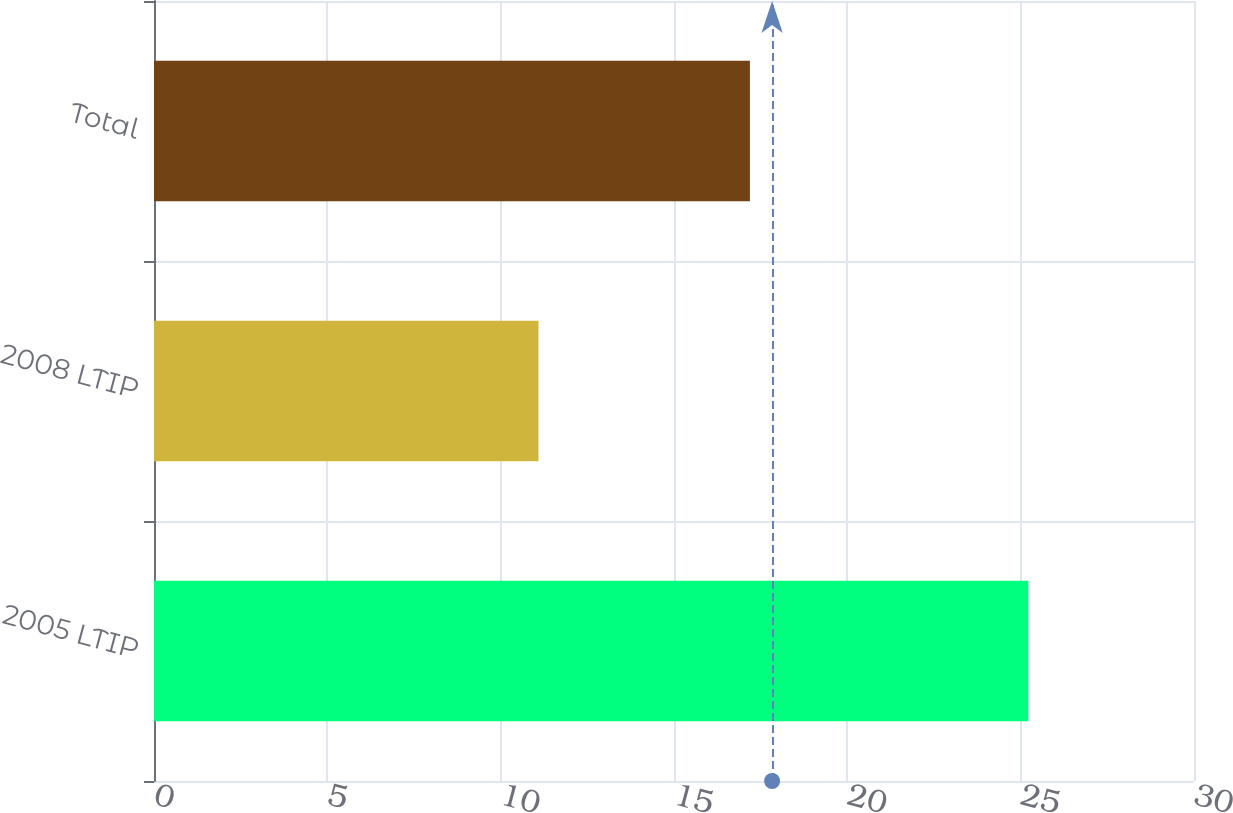<chart> <loc_0><loc_0><loc_500><loc_500><bar_chart><fcel>2005 LTIP<fcel>2008 LTIP<fcel>Total<nl><fcel>25.22<fcel>11.09<fcel>17.19<nl></chart> 